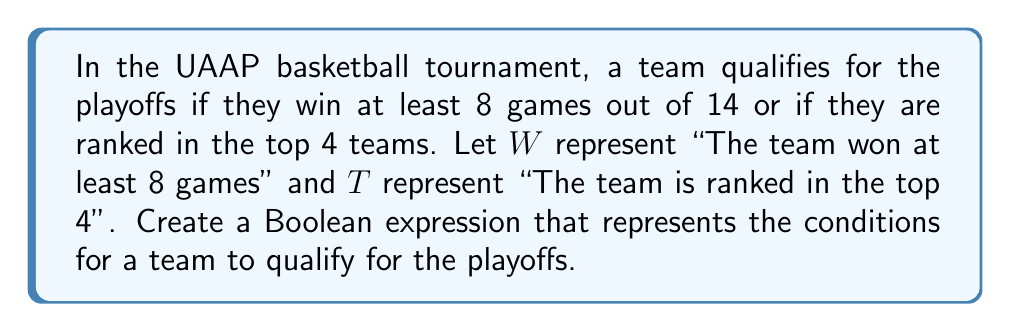Can you answer this question? To create a Boolean expression for this scenario, we need to consider the conditions that allow a team to qualify for the playoffs. Let's break it down step-by-step:

1. A team qualifies if they win at least 8 games (W) OR if they are ranked in the top 4 (T).

2. In Boolean algebra, the OR operation is represented by the + symbol.

3. Therefore, we can express the qualification condition as:

   $$ Q = W + T $$

   Where Q represents "The team qualifies for the playoffs"

4. This expression means that Q is true (1) if either W is true (1) or T is true (1), or both are true.

5. In terms of a truth table, this would look like:

   | W | T | Q |
   |---|---|---|
   | 0 | 0 | 0 |
   | 0 | 1 | 1 |
   | 1 | 0 | 1 |
   | 1 | 1 | 1 |

6. The expression $W + T$ is the simplest form that accurately represents the given conditions for playoff qualification.
Answer: $W + T$ 